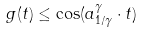<formula> <loc_0><loc_0><loc_500><loc_500>g ( t ) \leq \cos ( a _ { 1 / \gamma } ^ { \gamma } \cdot t )</formula> 